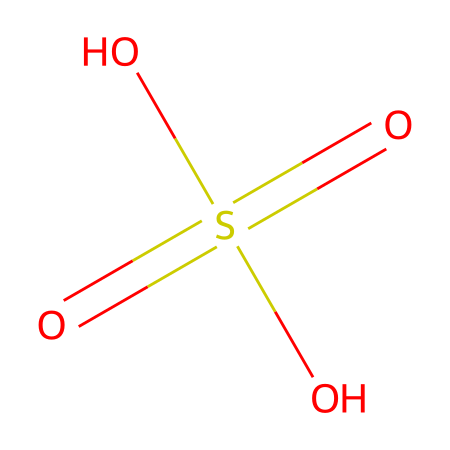What is the chemical formula of this substance? The chemical is represented by the SMILES notation O=S(=O)(O)O, which corresponds to its molecular formula consisting of one sulfur atom, four oxygen atoms, and two hydrogen atoms (H2SO4).
Answer: H2SO4 How many oxygen atoms are present in the molecule? By examining the SMILES representation O=S(=O)(O)O, we can count the number of oxygen atoms, which appears as three distinct 'O' symbols in the structure, indicating there are four oxygen atoms in total.
Answer: four Is this substance a strong or weak acid? Sulfuric acid, represented by the structure O=S(=O)(O)O, is known to be a strong acid because it completely dissociates in water, releasing H+ ions.
Answer: strong What role does sulfuric acid play in semiconductor manufacturing? In semiconductor manufacturing, sulfuric acid is used primarily for cleaning silicon wafers, as it effectively removes contaminants and organic materials due to its strong oxidizing properties.
Answer: cleaning agent What type of chemical compound is represented by this structure? The structure O=S(=O)(O)O shows characteristics of an acid, including the presence of hydrogen ions (H+) and its ability to donate protons in an aqueous solution, classifying it as a strong acid.
Answer: acid 